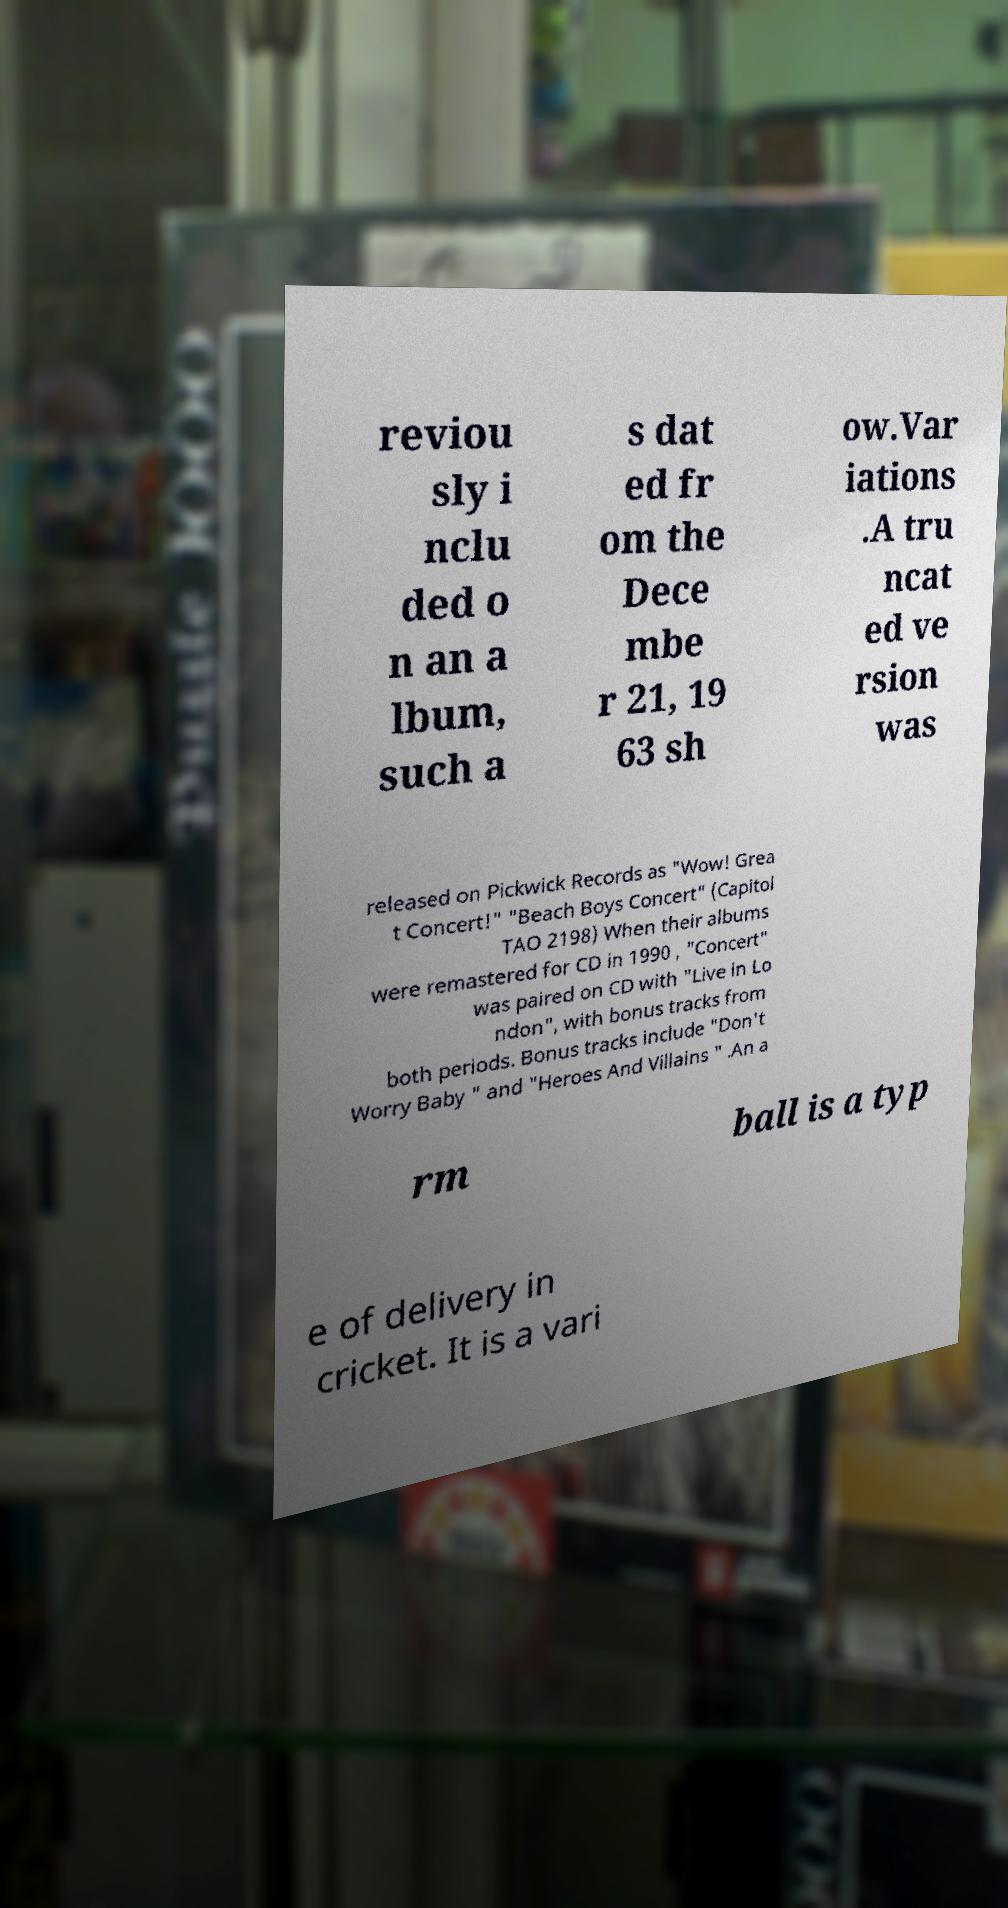Please read and relay the text visible in this image. What does it say? reviou sly i nclu ded o n an a lbum, such a s dat ed fr om the Dece mbe r 21, 19 63 sh ow.Var iations .A tru ncat ed ve rsion was released on Pickwick Records as "Wow! Grea t Concert!" "Beach Boys Concert" (Capitol TAO 2198) When their albums were remastered for CD in 1990 , "Concert" was paired on CD with "Live in Lo ndon", with bonus tracks from both periods. Bonus tracks include "Don't Worry Baby " and "Heroes And Villains " .An a rm ball is a typ e of delivery in cricket. It is a vari 